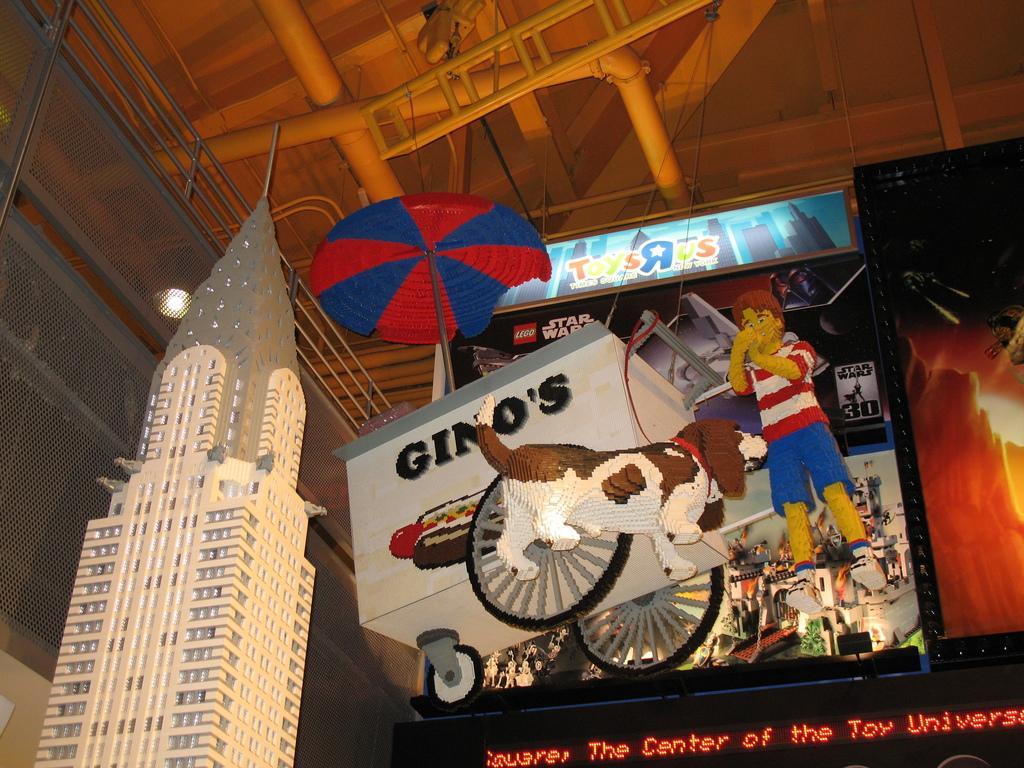How would you summarize this image in a sentence or two? In the picture we can see an art of the tower building and beside it, we can see a cart, dog and a cartoon by and an umbrella behind it and to the ceiling we can see some pipes and the ladder. 